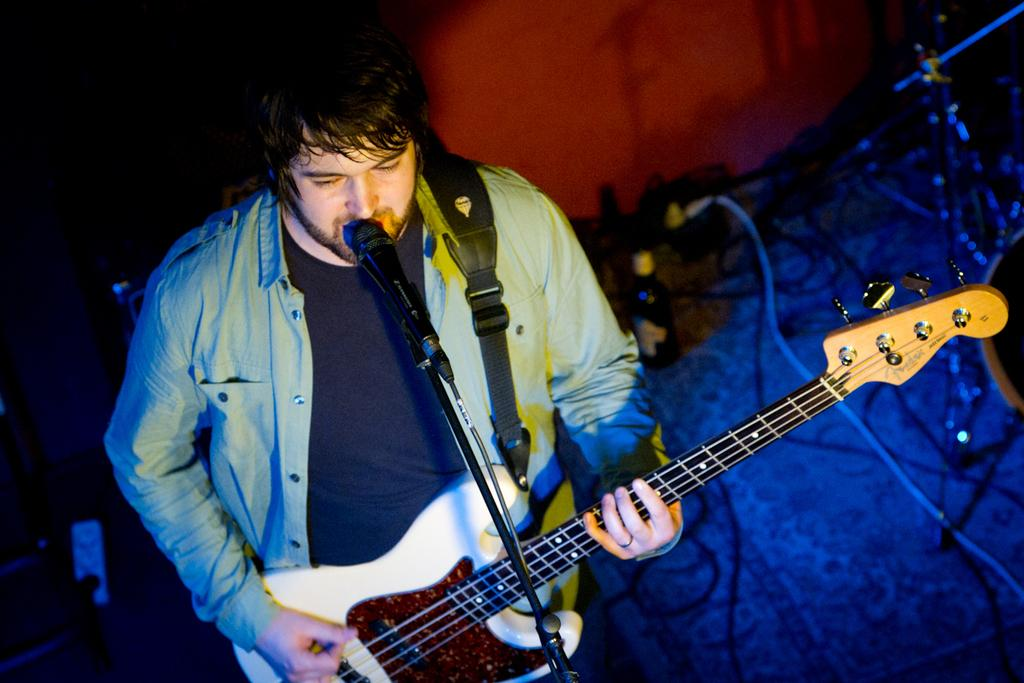Who is the main subject in the image? There is a man in the image. What is the man doing in the image? The man is standing in front of a microphone and playing a guitar. What object can be seen near the man? There is a bottle in the image. What type of surface is visible in the image? The image shows a floor. What type of memory is the man trying to recall in the image? There is no indication in the image that the man is trying to recall any memory. Can you see any fangs in the image? There are no fangs present in the image. 